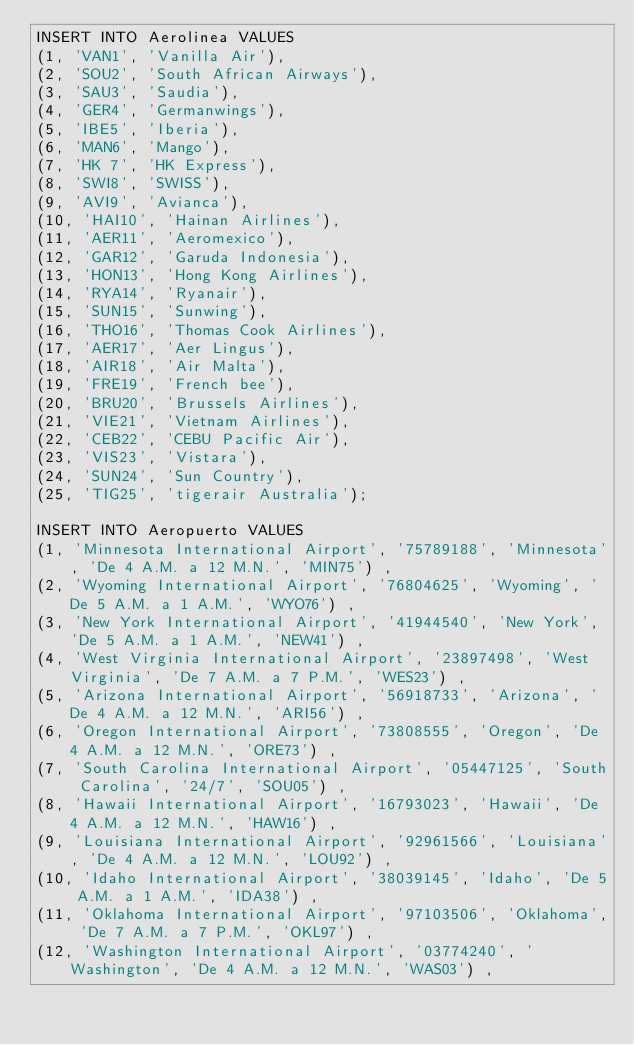<code> <loc_0><loc_0><loc_500><loc_500><_SQL_>INSERT INTO Aerolinea VALUES
(1, 'VAN1', 'Vanilla Air'), 
(2, 'SOU2', 'South African Airways'), 
(3, 'SAU3', 'Saudia'), 
(4, 'GER4', 'Germanwings'),
(5, 'IBE5', 'Iberia'),
(6, 'MAN6', 'Mango'),
(7, 'HK 7', 'HK Express'), 
(8, 'SWI8', 'SWISS'),
(9, 'AVI9', 'Avianca'), 
(10, 'HAI10', 'Hainan Airlines'), 
(11, 'AER11', 'Aeromexico'), 
(12, 'GAR12', 'Garuda Indonesia'), 
(13, 'HON13', 'Hong Kong Airlines'),
(14, 'RYA14', 'Ryanair'),
(15, 'SUN15', 'Sunwing'), 
(16, 'THO16', 'Thomas Cook Airlines'), 
(17, 'AER17', 'Aer Lingus'), 
(18, 'AIR18', 'Air Malta'), 
(19, 'FRE19', 'French bee'), 
(20, 'BRU20', 'Brussels Airlines'), 
(21, 'VIE21', 'Vietnam Airlines'), 
(22, 'CEB22', 'CEBU Pacific Air'), 
(23, 'VIS23', 'Vistara'), 
(24, 'SUN24', 'Sun Country'), 
(25, 'TIG25', 'tigerair Australia');

INSERT INTO Aeropuerto VALUES
(1, 'Minnesota International Airport', '75789188', 'Minnesota', 'De 4 A.M. a 12 M.N.', 'MIN75') ,
(2, 'Wyoming International Airport', '76804625', 'Wyoming', 'De 5 A.M. a 1 A.M.', 'WYO76') ,
(3, 'New York International Airport', '41944540', 'New York', 'De 5 A.M. a 1 A.M.', 'NEW41') ,
(4, 'West Virginia International Airport', '23897498', 'West Virginia', 'De 7 A.M. a 7 P.M.', 'WES23') ,
(5, 'Arizona International Airport', '56918733', 'Arizona', 'De 4 A.M. a 12 M.N.', 'ARI56') ,
(6, 'Oregon International Airport', '73808555', 'Oregon', 'De 4 A.M. a 12 M.N.', 'ORE73') ,
(7, 'South Carolina International Airport', '05447125', 'South Carolina', '24/7', 'SOU05') ,
(8, 'Hawaii International Airport', '16793023', 'Hawaii', 'De 4 A.M. a 12 M.N.', 'HAW16') ,
(9, 'Louisiana International Airport', '92961566', 'Louisiana', 'De 4 A.M. a 12 M.N.', 'LOU92') ,
(10, 'Idaho International Airport', '38039145', 'Idaho', 'De 5 A.M. a 1 A.M.', 'IDA38') ,
(11, 'Oklahoma International Airport', '97103506', 'Oklahoma', 'De 7 A.M. a 7 P.M.', 'OKL97') ,
(12, 'Washington International Airport', '03774240', 'Washington', 'De 4 A.M. a 12 M.N.', 'WAS03') ,</code> 